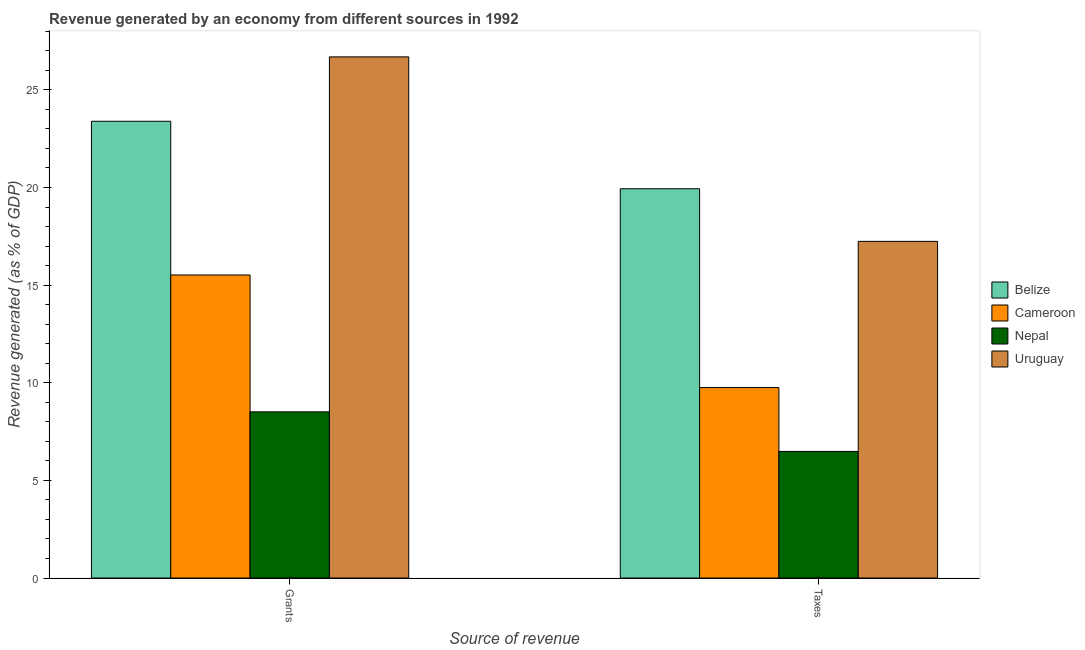Are the number of bars on each tick of the X-axis equal?
Offer a very short reply. Yes. How many bars are there on the 1st tick from the left?
Your answer should be very brief. 4. What is the label of the 2nd group of bars from the left?
Provide a short and direct response. Taxes. What is the revenue generated by taxes in Belize?
Give a very brief answer. 19.94. Across all countries, what is the maximum revenue generated by grants?
Make the answer very short. 26.69. Across all countries, what is the minimum revenue generated by grants?
Give a very brief answer. 8.51. In which country was the revenue generated by grants maximum?
Keep it short and to the point. Uruguay. In which country was the revenue generated by grants minimum?
Your response must be concise. Nepal. What is the total revenue generated by taxes in the graph?
Ensure brevity in your answer.  53.41. What is the difference between the revenue generated by taxes in Nepal and that in Cameroon?
Your answer should be compact. -3.27. What is the difference between the revenue generated by grants in Cameroon and the revenue generated by taxes in Nepal?
Make the answer very short. 9.04. What is the average revenue generated by taxes per country?
Provide a succinct answer. 13.35. What is the difference between the revenue generated by grants and revenue generated by taxes in Cameroon?
Your answer should be compact. 5.77. What is the ratio of the revenue generated by grants in Cameroon to that in Nepal?
Keep it short and to the point. 1.82. Is the revenue generated by taxes in Nepal less than that in Cameroon?
Provide a short and direct response. Yes. What does the 2nd bar from the left in Taxes represents?
Your response must be concise. Cameroon. What does the 2nd bar from the right in Grants represents?
Offer a terse response. Nepal. What is the difference between two consecutive major ticks on the Y-axis?
Give a very brief answer. 5. How many legend labels are there?
Ensure brevity in your answer.  4. What is the title of the graph?
Your answer should be compact. Revenue generated by an economy from different sources in 1992. What is the label or title of the X-axis?
Keep it short and to the point. Source of revenue. What is the label or title of the Y-axis?
Provide a short and direct response. Revenue generated (as % of GDP). What is the Revenue generated (as % of GDP) of Belize in Grants?
Your response must be concise. 23.39. What is the Revenue generated (as % of GDP) of Cameroon in Grants?
Your answer should be very brief. 15.52. What is the Revenue generated (as % of GDP) of Nepal in Grants?
Give a very brief answer. 8.51. What is the Revenue generated (as % of GDP) in Uruguay in Grants?
Your answer should be very brief. 26.69. What is the Revenue generated (as % of GDP) in Belize in Taxes?
Offer a very short reply. 19.94. What is the Revenue generated (as % of GDP) in Cameroon in Taxes?
Provide a succinct answer. 9.75. What is the Revenue generated (as % of GDP) of Nepal in Taxes?
Make the answer very short. 6.48. What is the Revenue generated (as % of GDP) in Uruguay in Taxes?
Ensure brevity in your answer.  17.24. Across all Source of revenue, what is the maximum Revenue generated (as % of GDP) in Belize?
Offer a terse response. 23.39. Across all Source of revenue, what is the maximum Revenue generated (as % of GDP) in Cameroon?
Provide a succinct answer. 15.52. Across all Source of revenue, what is the maximum Revenue generated (as % of GDP) of Nepal?
Your answer should be very brief. 8.51. Across all Source of revenue, what is the maximum Revenue generated (as % of GDP) in Uruguay?
Keep it short and to the point. 26.69. Across all Source of revenue, what is the minimum Revenue generated (as % of GDP) in Belize?
Offer a terse response. 19.94. Across all Source of revenue, what is the minimum Revenue generated (as % of GDP) of Cameroon?
Make the answer very short. 9.75. Across all Source of revenue, what is the minimum Revenue generated (as % of GDP) of Nepal?
Provide a succinct answer. 6.48. Across all Source of revenue, what is the minimum Revenue generated (as % of GDP) of Uruguay?
Your answer should be compact. 17.24. What is the total Revenue generated (as % of GDP) of Belize in the graph?
Make the answer very short. 43.33. What is the total Revenue generated (as % of GDP) in Cameroon in the graph?
Your answer should be compact. 25.27. What is the total Revenue generated (as % of GDP) of Nepal in the graph?
Your response must be concise. 14.99. What is the total Revenue generated (as % of GDP) in Uruguay in the graph?
Provide a short and direct response. 43.93. What is the difference between the Revenue generated (as % of GDP) in Belize in Grants and that in Taxes?
Keep it short and to the point. 3.45. What is the difference between the Revenue generated (as % of GDP) of Cameroon in Grants and that in Taxes?
Keep it short and to the point. 5.77. What is the difference between the Revenue generated (as % of GDP) in Nepal in Grants and that in Taxes?
Provide a short and direct response. 2.03. What is the difference between the Revenue generated (as % of GDP) of Uruguay in Grants and that in Taxes?
Offer a very short reply. 9.45. What is the difference between the Revenue generated (as % of GDP) in Belize in Grants and the Revenue generated (as % of GDP) in Cameroon in Taxes?
Your answer should be very brief. 13.64. What is the difference between the Revenue generated (as % of GDP) in Belize in Grants and the Revenue generated (as % of GDP) in Nepal in Taxes?
Offer a terse response. 16.91. What is the difference between the Revenue generated (as % of GDP) in Belize in Grants and the Revenue generated (as % of GDP) in Uruguay in Taxes?
Ensure brevity in your answer.  6.15. What is the difference between the Revenue generated (as % of GDP) in Cameroon in Grants and the Revenue generated (as % of GDP) in Nepal in Taxes?
Your answer should be compact. 9.04. What is the difference between the Revenue generated (as % of GDP) of Cameroon in Grants and the Revenue generated (as % of GDP) of Uruguay in Taxes?
Offer a terse response. -1.72. What is the difference between the Revenue generated (as % of GDP) in Nepal in Grants and the Revenue generated (as % of GDP) in Uruguay in Taxes?
Your response must be concise. -8.73. What is the average Revenue generated (as % of GDP) of Belize per Source of revenue?
Provide a succinct answer. 21.66. What is the average Revenue generated (as % of GDP) of Cameroon per Source of revenue?
Offer a very short reply. 12.64. What is the average Revenue generated (as % of GDP) in Nepal per Source of revenue?
Offer a terse response. 7.5. What is the average Revenue generated (as % of GDP) in Uruguay per Source of revenue?
Offer a very short reply. 21.96. What is the difference between the Revenue generated (as % of GDP) in Belize and Revenue generated (as % of GDP) in Cameroon in Grants?
Provide a succinct answer. 7.87. What is the difference between the Revenue generated (as % of GDP) of Belize and Revenue generated (as % of GDP) of Nepal in Grants?
Provide a succinct answer. 14.88. What is the difference between the Revenue generated (as % of GDP) in Belize and Revenue generated (as % of GDP) in Uruguay in Grants?
Make the answer very short. -3.3. What is the difference between the Revenue generated (as % of GDP) of Cameroon and Revenue generated (as % of GDP) of Nepal in Grants?
Give a very brief answer. 7.01. What is the difference between the Revenue generated (as % of GDP) of Cameroon and Revenue generated (as % of GDP) of Uruguay in Grants?
Keep it short and to the point. -11.17. What is the difference between the Revenue generated (as % of GDP) of Nepal and Revenue generated (as % of GDP) of Uruguay in Grants?
Your answer should be very brief. -18.18. What is the difference between the Revenue generated (as % of GDP) in Belize and Revenue generated (as % of GDP) in Cameroon in Taxes?
Offer a terse response. 10.18. What is the difference between the Revenue generated (as % of GDP) in Belize and Revenue generated (as % of GDP) in Nepal in Taxes?
Your response must be concise. 13.45. What is the difference between the Revenue generated (as % of GDP) of Belize and Revenue generated (as % of GDP) of Uruguay in Taxes?
Your answer should be compact. 2.69. What is the difference between the Revenue generated (as % of GDP) of Cameroon and Revenue generated (as % of GDP) of Nepal in Taxes?
Ensure brevity in your answer.  3.27. What is the difference between the Revenue generated (as % of GDP) in Cameroon and Revenue generated (as % of GDP) in Uruguay in Taxes?
Keep it short and to the point. -7.49. What is the difference between the Revenue generated (as % of GDP) of Nepal and Revenue generated (as % of GDP) of Uruguay in Taxes?
Provide a succinct answer. -10.76. What is the ratio of the Revenue generated (as % of GDP) in Belize in Grants to that in Taxes?
Ensure brevity in your answer.  1.17. What is the ratio of the Revenue generated (as % of GDP) in Cameroon in Grants to that in Taxes?
Your answer should be very brief. 1.59. What is the ratio of the Revenue generated (as % of GDP) of Nepal in Grants to that in Taxes?
Offer a terse response. 1.31. What is the ratio of the Revenue generated (as % of GDP) in Uruguay in Grants to that in Taxes?
Your answer should be very brief. 1.55. What is the difference between the highest and the second highest Revenue generated (as % of GDP) of Belize?
Give a very brief answer. 3.45. What is the difference between the highest and the second highest Revenue generated (as % of GDP) in Cameroon?
Provide a short and direct response. 5.77. What is the difference between the highest and the second highest Revenue generated (as % of GDP) in Nepal?
Offer a terse response. 2.03. What is the difference between the highest and the second highest Revenue generated (as % of GDP) in Uruguay?
Provide a short and direct response. 9.45. What is the difference between the highest and the lowest Revenue generated (as % of GDP) in Belize?
Your response must be concise. 3.45. What is the difference between the highest and the lowest Revenue generated (as % of GDP) in Cameroon?
Make the answer very short. 5.77. What is the difference between the highest and the lowest Revenue generated (as % of GDP) in Nepal?
Your response must be concise. 2.03. What is the difference between the highest and the lowest Revenue generated (as % of GDP) in Uruguay?
Give a very brief answer. 9.45. 